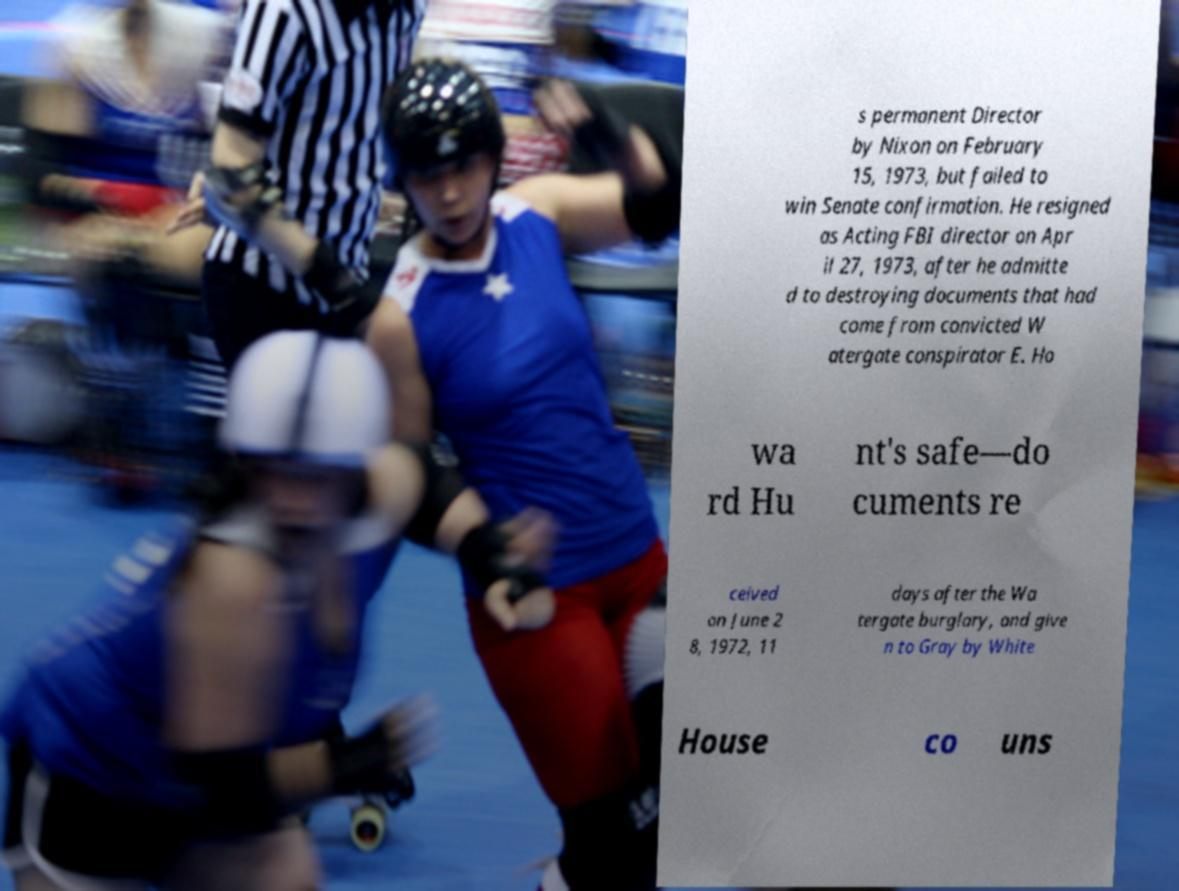What messages or text are displayed in this image? I need them in a readable, typed format. s permanent Director by Nixon on February 15, 1973, but failed to win Senate confirmation. He resigned as Acting FBI director on Apr il 27, 1973, after he admitte d to destroying documents that had come from convicted W atergate conspirator E. Ho wa rd Hu nt's safe—do cuments re ceived on June 2 8, 1972, 11 days after the Wa tergate burglary, and give n to Gray by White House co uns 